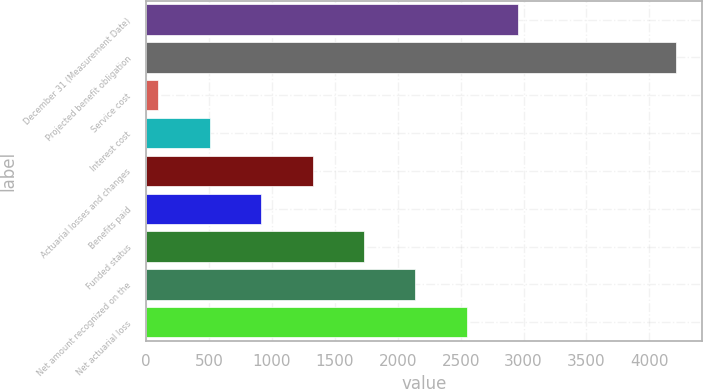<chart> <loc_0><loc_0><loc_500><loc_500><bar_chart><fcel>December 31 (Measurement Date)<fcel>Projected benefit obligation<fcel>Service cost<fcel>Interest cost<fcel>Actuarial losses and changes<fcel>Benefits paid<fcel>Funded status<fcel>Net amount recognized on the<fcel>Net actuarial loss<nl><fcel>2959.8<fcel>4212.4<fcel>94<fcel>503.4<fcel>1322.2<fcel>912.8<fcel>1731.6<fcel>2141<fcel>2550.4<nl></chart> 